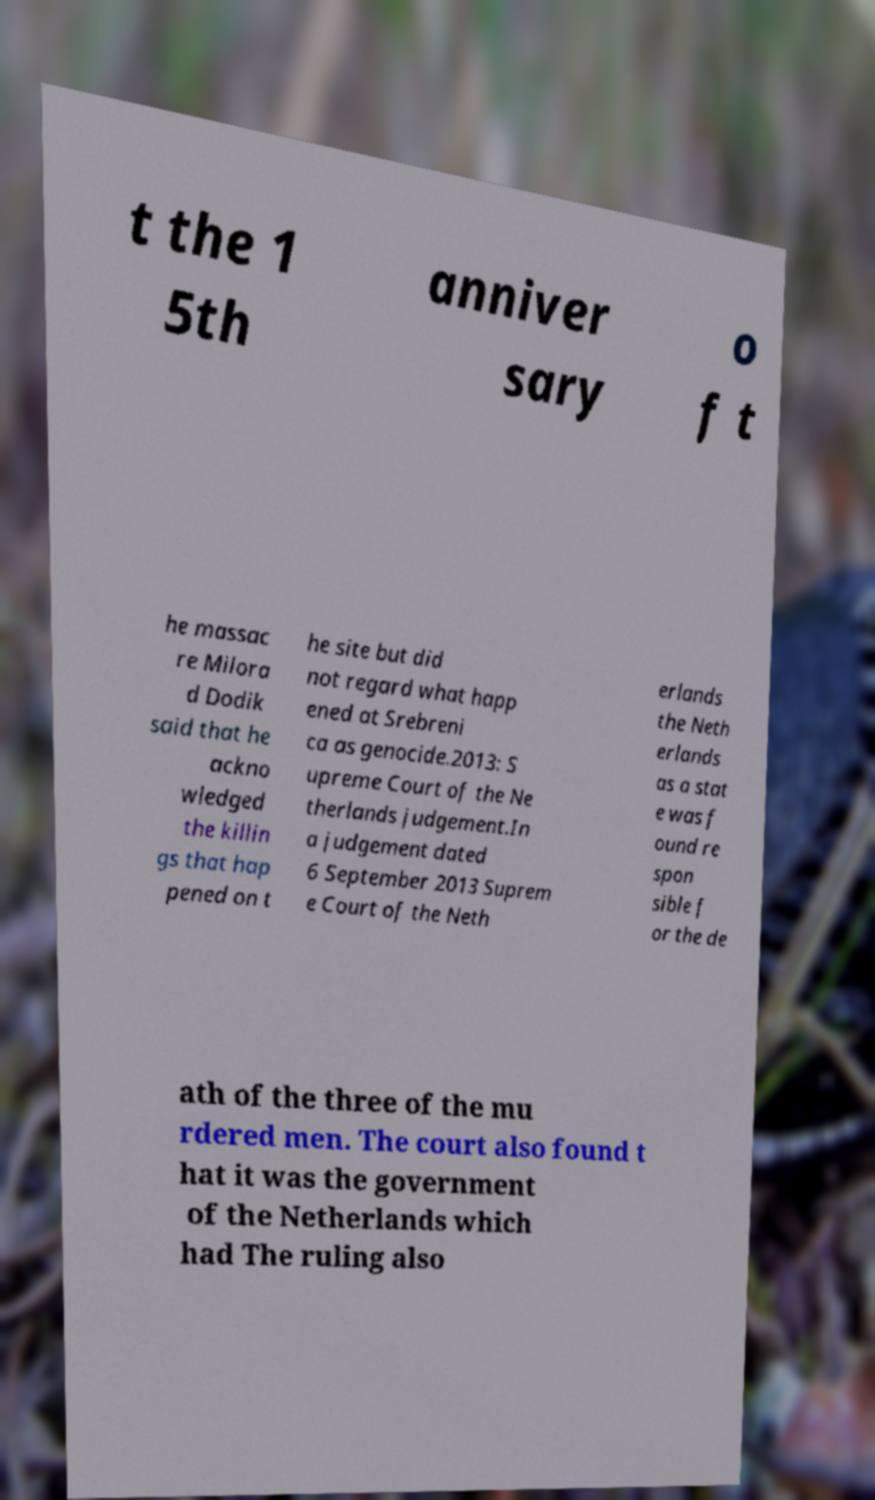Can you read and provide the text displayed in the image?This photo seems to have some interesting text. Can you extract and type it out for me? t the 1 5th anniver sary o f t he massac re Milora d Dodik said that he ackno wledged the killin gs that hap pened on t he site but did not regard what happ ened at Srebreni ca as genocide.2013: S upreme Court of the Ne therlands judgement.In a judgement dated 6 September 2013 Suprem e Court of the Neth erlands the Neth erlands as a stat e was f ound re spon sible f or the de ath of the three of the mu rdered men. The court also found t hat it was the government of the Netherlands which had The ruling also 